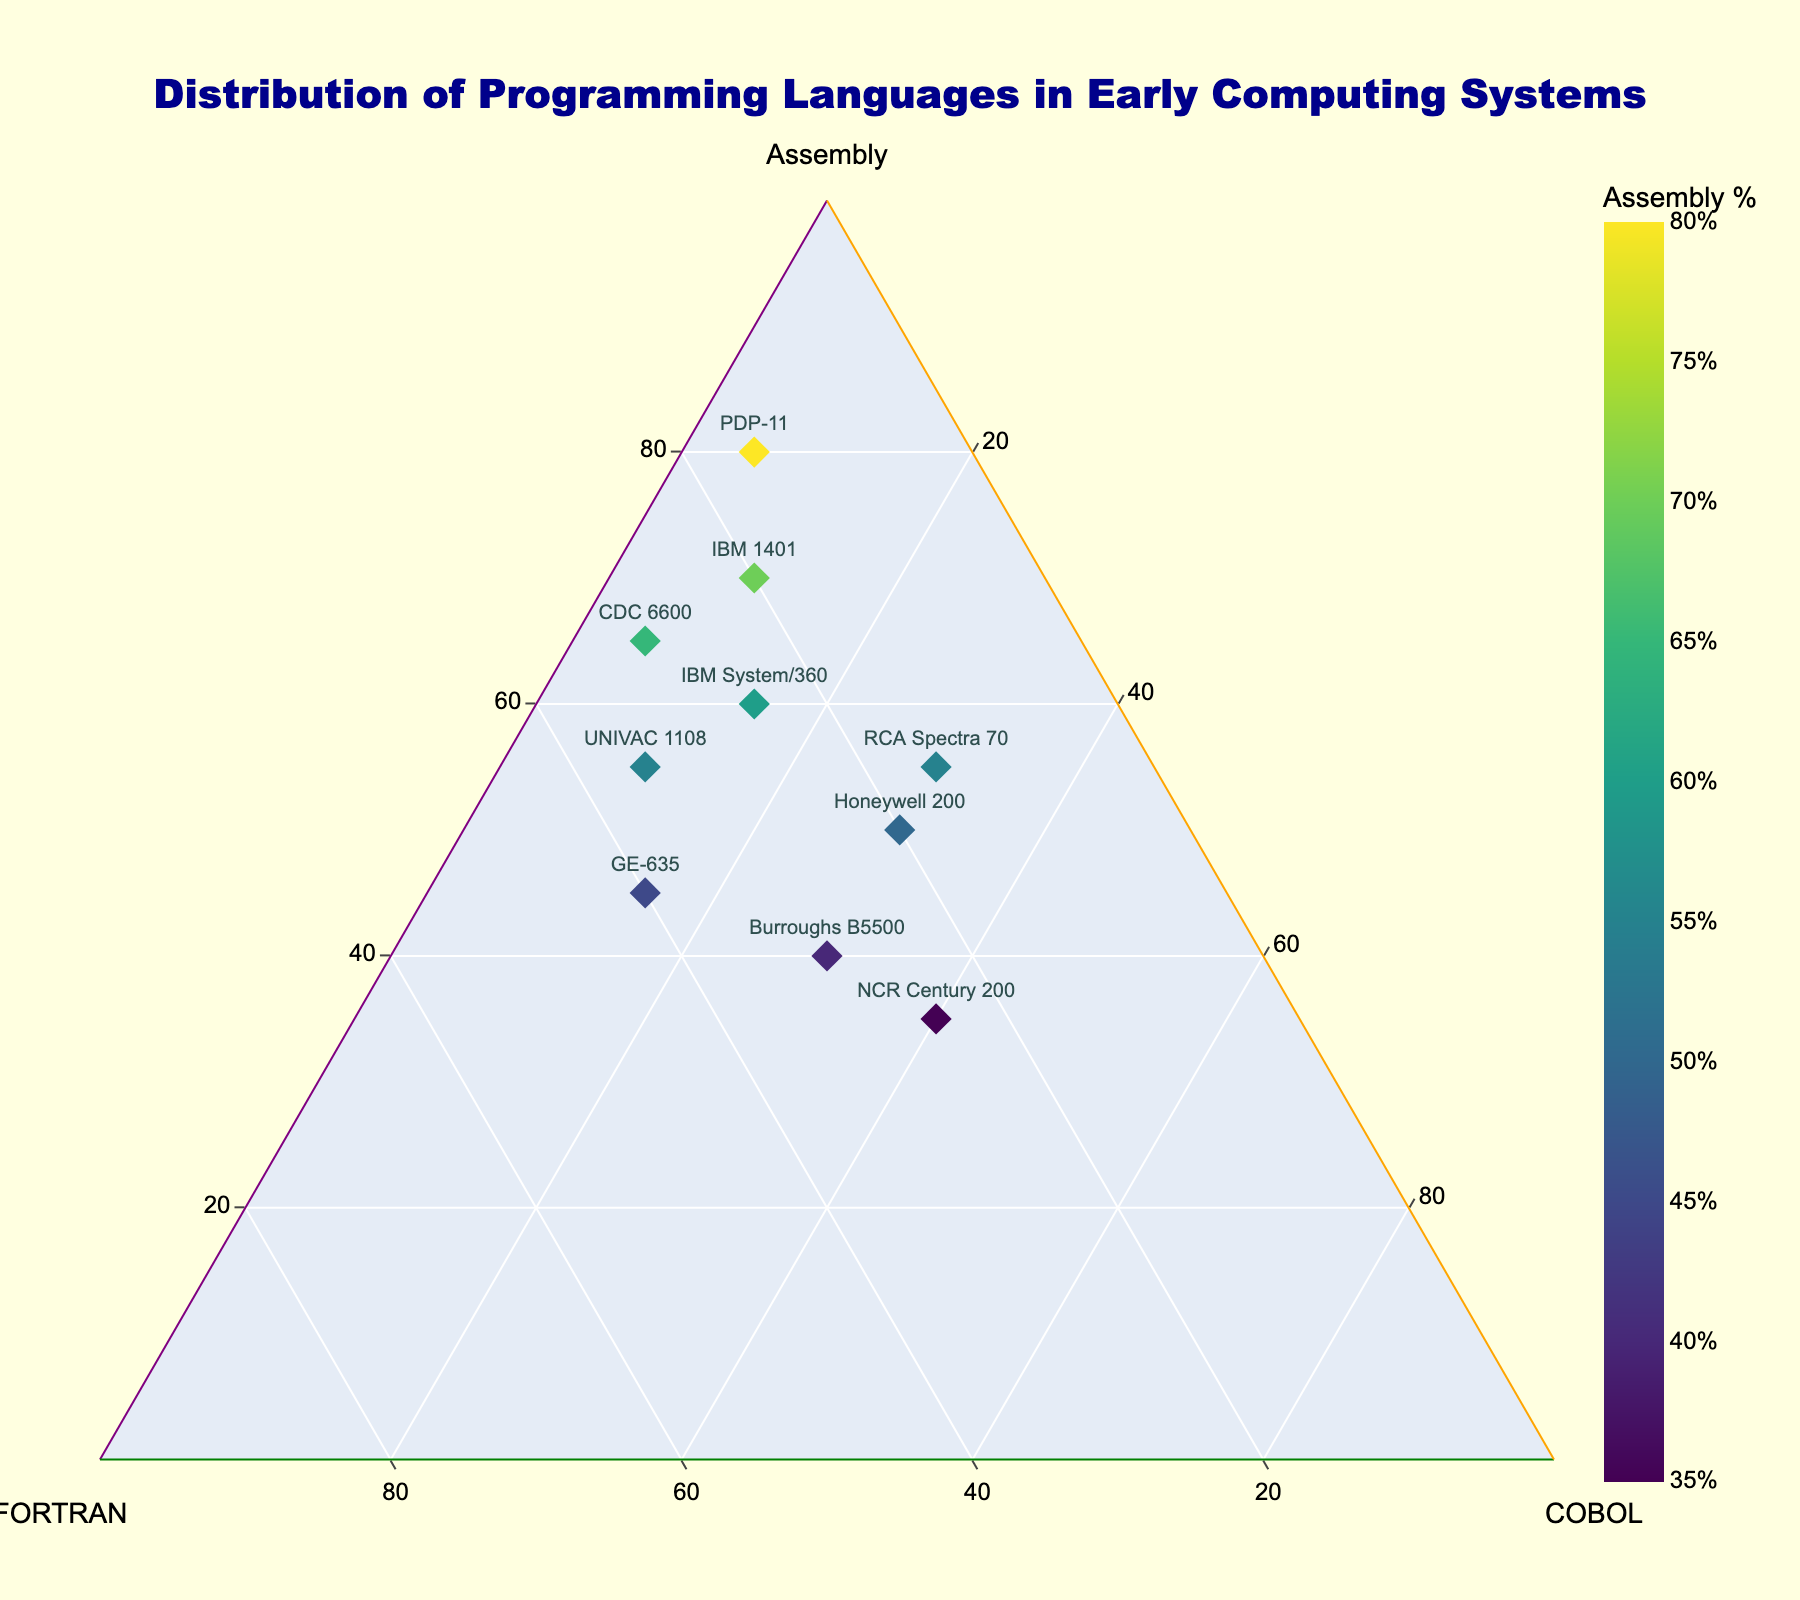What is the title of the plot? The title is shown at the top of the plot.
Answer: Distribution of Programming Languages in Early Computing Systems How many computing systems are displayed in the plot? Look at the number of markers or labels corresponding to different system names. There are 10 computing systems in the plot.
Answer: 10 Which computing system has the highest percentage of Assembly usage? Check the marker positioned closest to the "Assembly" axis, noted with the highest value for Assembly. It's the 'PDP-11' with 80%.
Answer: PDP-11 What is the distribution (Assembly, FORTRAN, COBOL) for the 'Burroughs B5500' system? Find the label 'Burroughs B5500' and check the values alongside it. Assembly: 40%, FORTRAN: 30%, COBOL: 30%.
Answer: 40% Assembly, 30% FORTRAN, 30% COBOL Which computing system has an equal percentage of FORTRAN and COBOL? Search for a system whose percentages of FORTRAN and COBOL are equal. The 'Burroughs B5500' has both FORTRAN and COBOL at 30% each.
Answer: Burroughs B5500 What is the average percentage of COBOL among all the systems? Sum the COBOL percentages and divide by the number of systems. (10+10+5+5+15+30+30+15+30+40)/10 = 190/10
Answer: 19% Which system uses the least FORTRAN? Locate the system with the smallest value on the FORTRAN axis. 'PDP-11' uses 15% FORTRAN.
Answer: PDP-11 Compare the IBM 1401 and IBM System/360 in terms of Assembly usage. Which one has a higher percentage? Assemble the Assembly percentages for both systems and compare them. IBM 1401 has 70% and IBM System/360 has 60%, hence IBM 1401 has a higher percentage.
Answer: IBM 1401 Which system has the most balanced usage of all three programming languages? Look for a system where the percentages are closest to each other. 'NCR Century 200' has 35% Assembly, 25% FORTRAN, and 40% COBOL.
Answer: NCR Century 200 What is the sum of the percentages for Assembly usage of all systems? Sum up all Assembly percentages from each system: 70+55+65+80+60+40+50+45+55+35 = 555.
Answer: 555% 